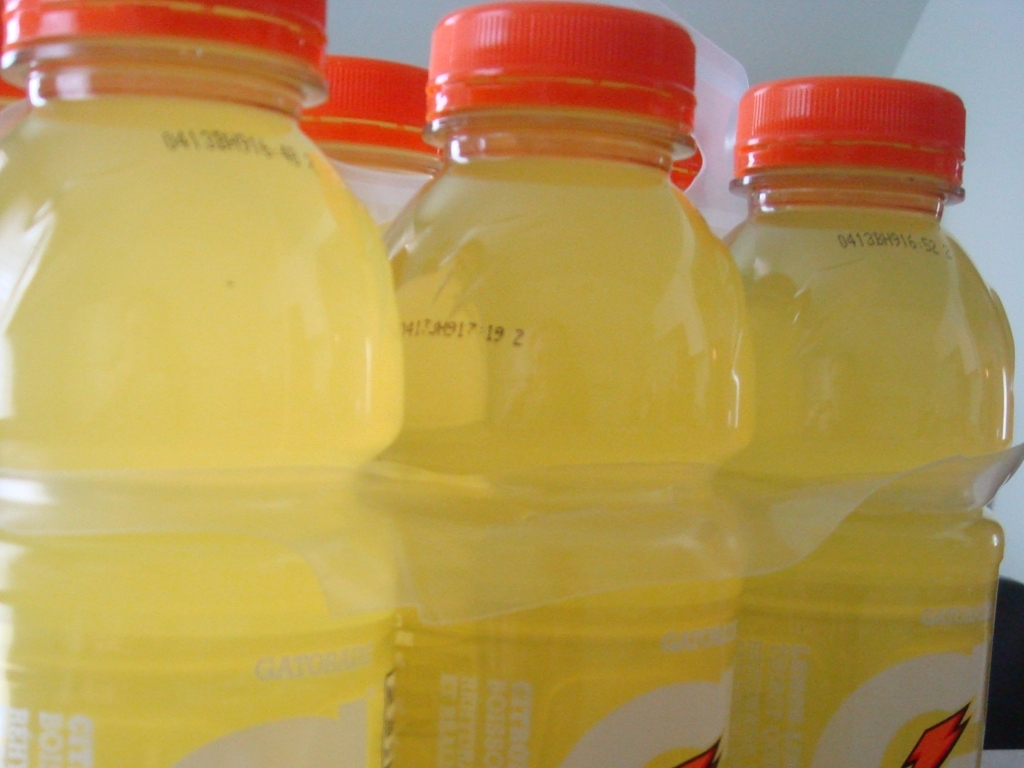What product is shown in the image? The image shows three bottles of a sports drink, recognizable by their distinctive branding and the liquid color. 